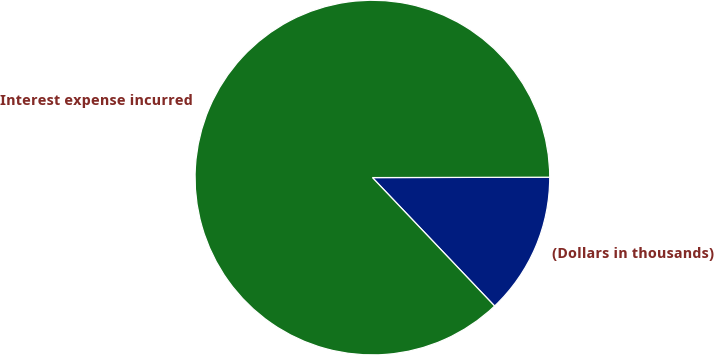<chart> <loc_0><loc_0><loc_500><loc_500><pie_chart><fcel>(Dollars in thousands)<fcel>Interest expense incurred<nl><fcel>12.93%<fcel>87.07%<nl></chart> 